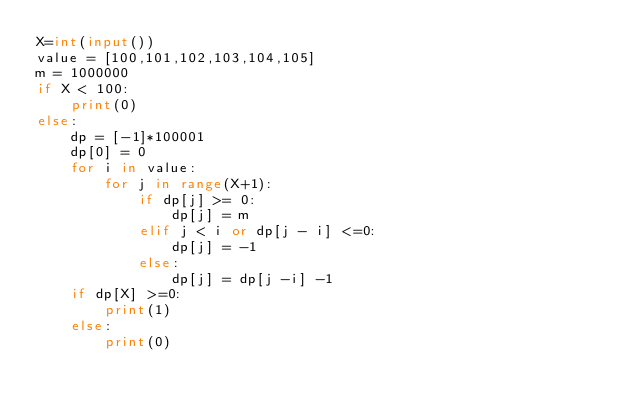<code> <loc_0><loc_0><loc_500><loc_500><_Python_>X=int(input())
value = [100,101,102,103,104,105]
m = 1000000
if X < 100:
    print(0)
else:
    dp = [-1]*100001
    dp[0] = 0
    for i in value:
        for j in range(X+1):
            if dp[j] >= 0:
                dp[j] = m
            elif j < i or dp[j - i] <=0:
                dp[j] = -1
            else:
                dp[j] = dp[j -i] -1
    if dp[X] >=0:
        print(1)
    else:
        print(0)</code> 